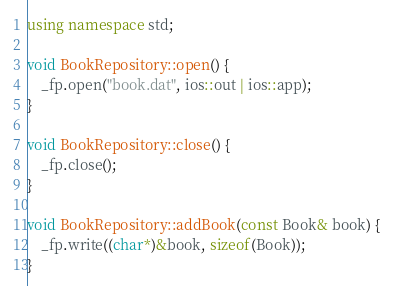<code> <loc_0><loc_0><loc_500><loc_500><_C++_>using namespace std;

void BookRepository::open() {
	_fp.open("book.dat", ios::out | ios::app);
}

void BookRepository::close() {
	_fp.close();
}

void BookRepository::addBook(const Book& book) {
	_fp.write((char*)&book, sizeof(Book));
}</code> 